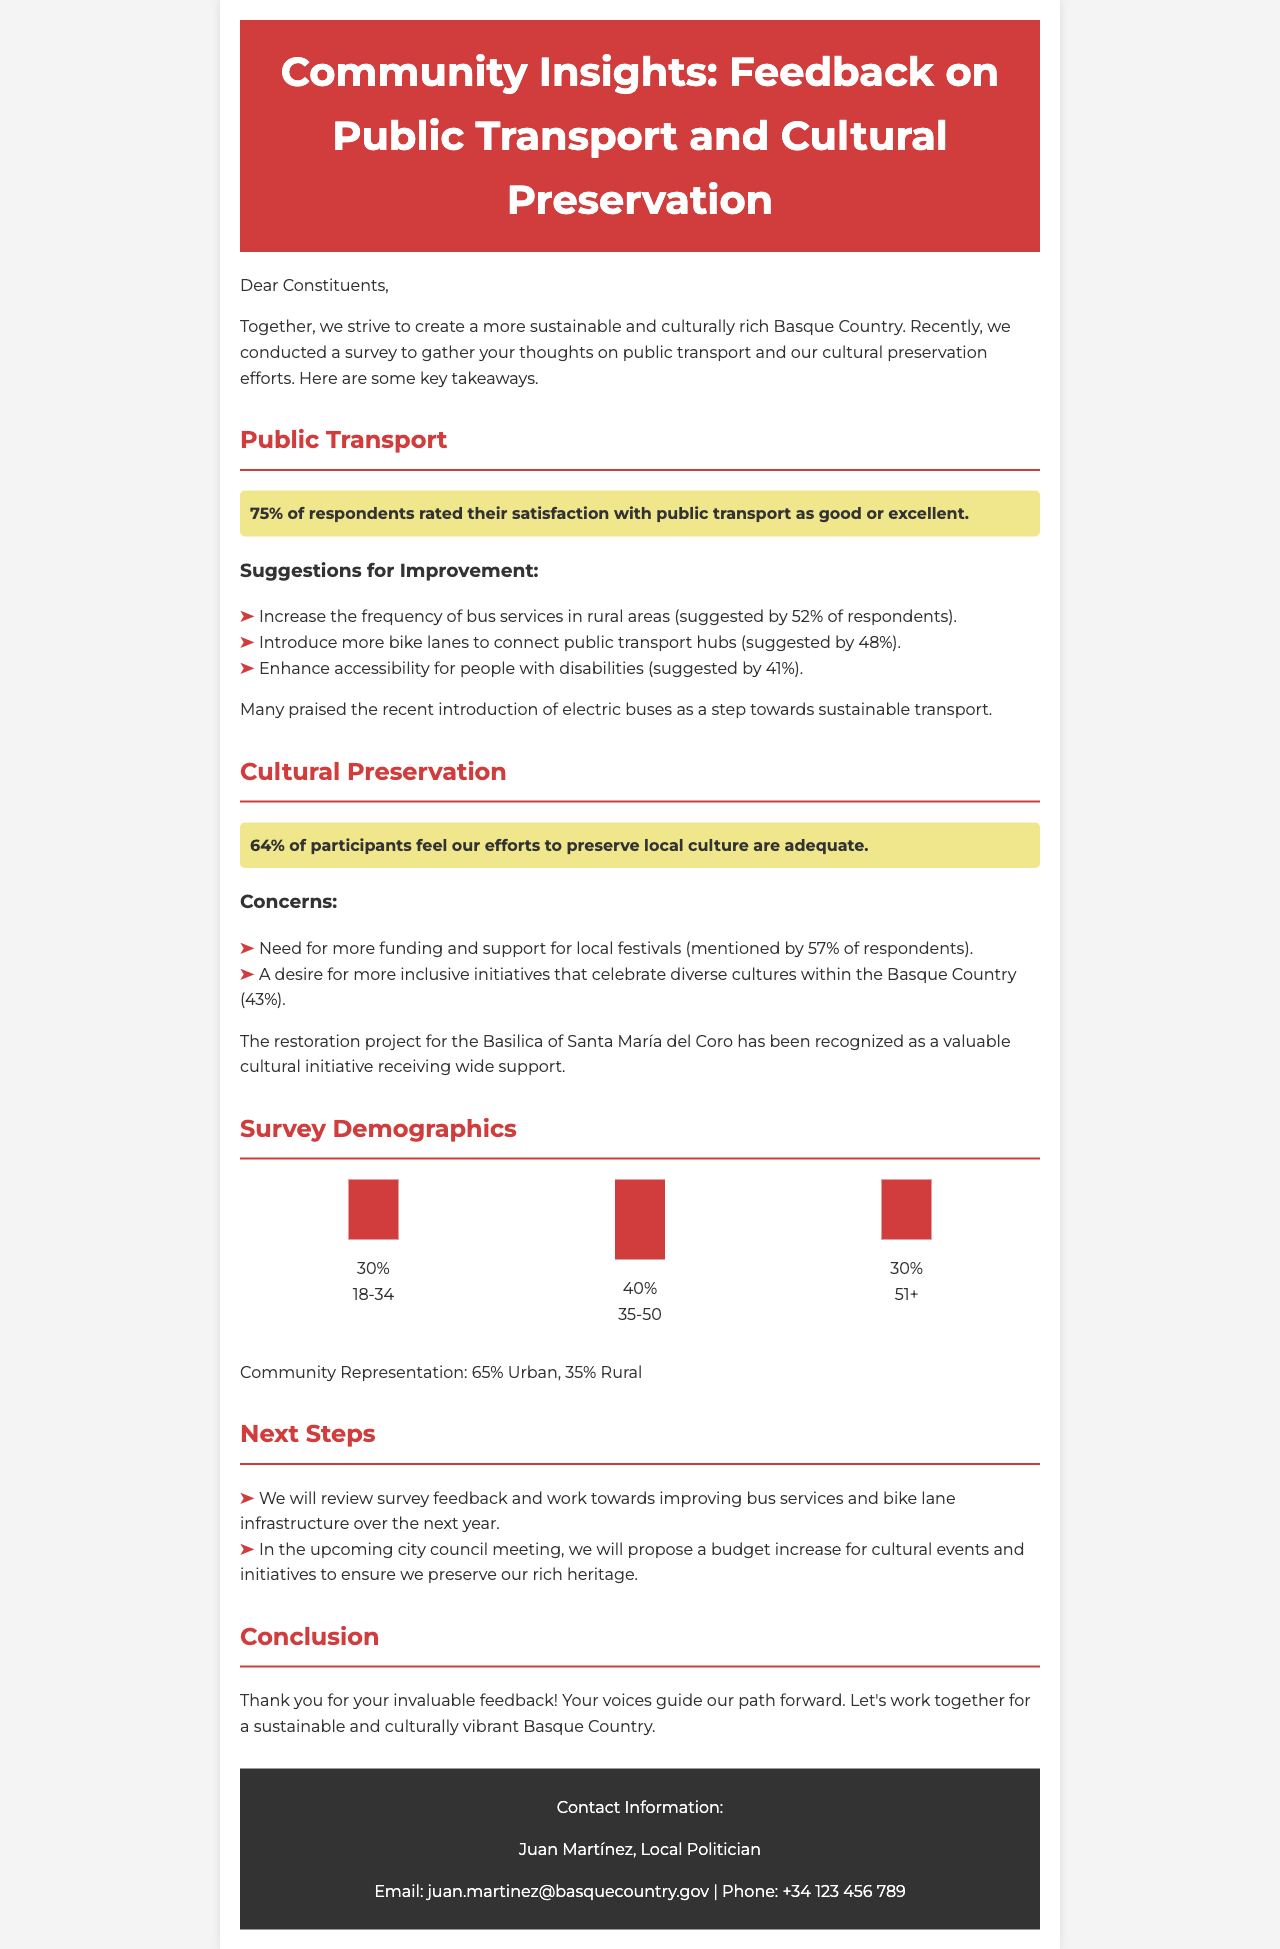What percentage of respondents rated their satisfaction with public transport as good or excellent? This information is directly stated in the document, indicating that 75% of respondents expressed satisfaction.
Answer: 75% What is the most frequent suggestion for improving public transport? The document highlights that the suggestion with the highest percentage, 52%, was to increase the frequency of bus services in rural areas.
Answer: Increase the frequency of bus services in rural areas How many respondents believe that the cultural preservation efforts are adequate? The document mentions that 64% of participants feel that the efforts to preserve local culture are adequate.
Answer: 64% What is the percentage of urban community representation in the survey? The document states the community representation as 65% urban, indicating the divide between urban and rural responses.
Answer: 65% What cultural initiative received wide support according to the feedback? The document references the restoration project for the Basilica of Santa María del Coro as a valuable cultural initiative.
Answer: Basilica of Santa María del Coro What percentage of participants expressed a desire for more inclusive cultural initiatives? The document reveals that 43% of respondents mentioned a desire for more inclusive initiatives celebrating diverse cultures.
Answer: 43% What is one of the next steps mentioned in the newsletter regarding public transport? The document outlines that one next step is to review feedback and work towards improving bus services over the next year.
Answer: Improve bus services Who is the contact person listed in the newsletter? The document provides the name of Juan Martínez as the local politician and contact person for constituents.
Answer: Juan Martínez 